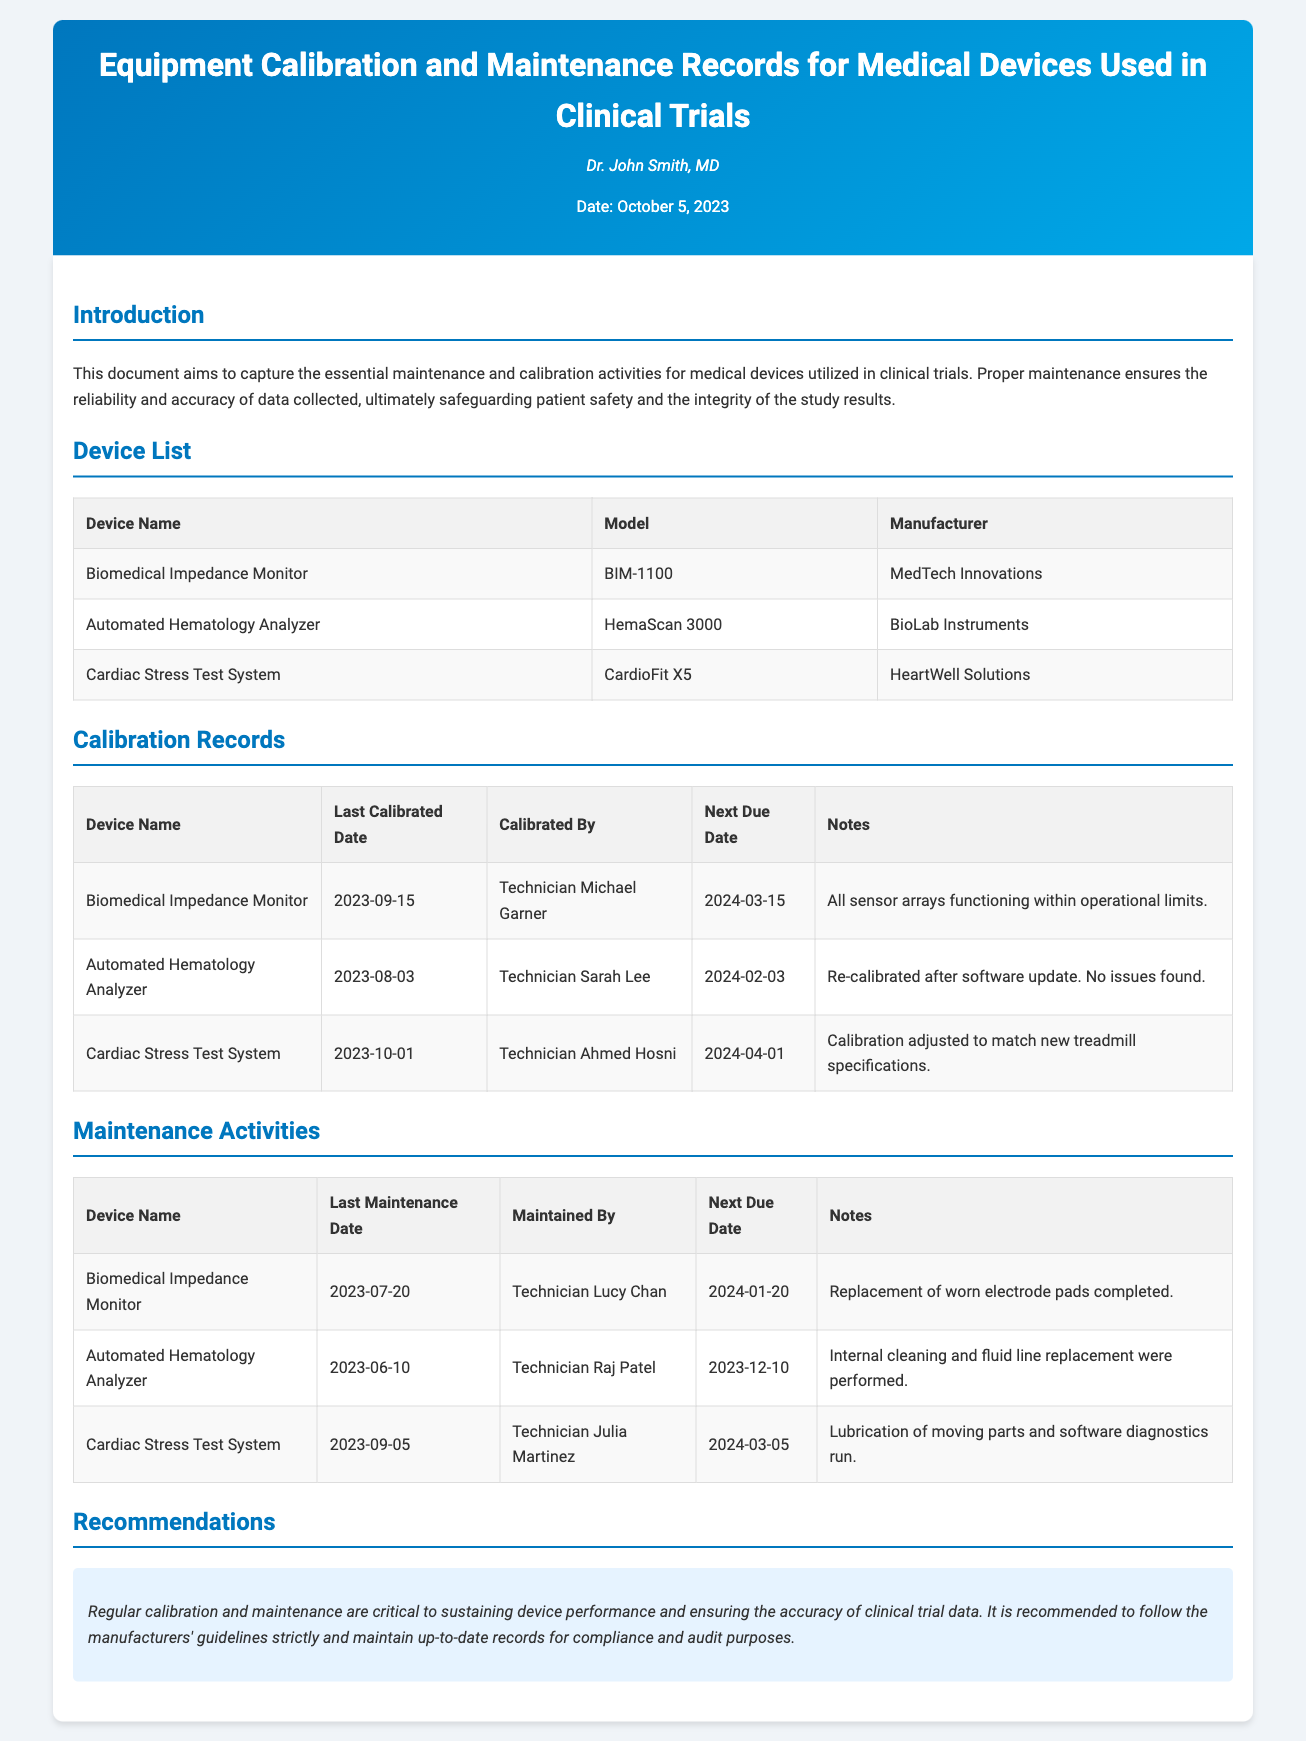What is the name of the document? The document's title is located in the header section that identifies its purpose.
Answer: Equipment Calibration and Maintenance Records for Medical Devices Used in Clinical Trials Who is the author of this document? The author's name is presented right below the title in the header.
Answer: Dr. John Smith, MD When was the Biomedical Impedance Monitor last calibrated? The last calibrated date for this device is recorded in the calibration records table.
Answer: 2023-09-15 What is the next due date for the Automated Hematology Analyzer's maintenance? The next due date is mentioned in the maintenance activities table associated with the device.
Answer: 2023-12-10 Which technician performed maintenance on the Cardiac Stress Test System? The name of the technician is listed in the maintenance activities table for this specific device.
Answer: Technician Julia Martinez What adjustment was made during the last calibration of the Cardiac Stress Test System? The notes section in the calibration records table provides the relevant information.
Answer: Calibration adjusted to match new treadmill specifications What is the recommendation highlighted in the document? The recommendations section gives a specific advice regarding device maintenance.
Answer: Regular calibration and maintenance are critical to sustaining device performance How many devices are listed in the document? The count of devices can be determined from the device list table provided in the document.
Answer: Three devices 